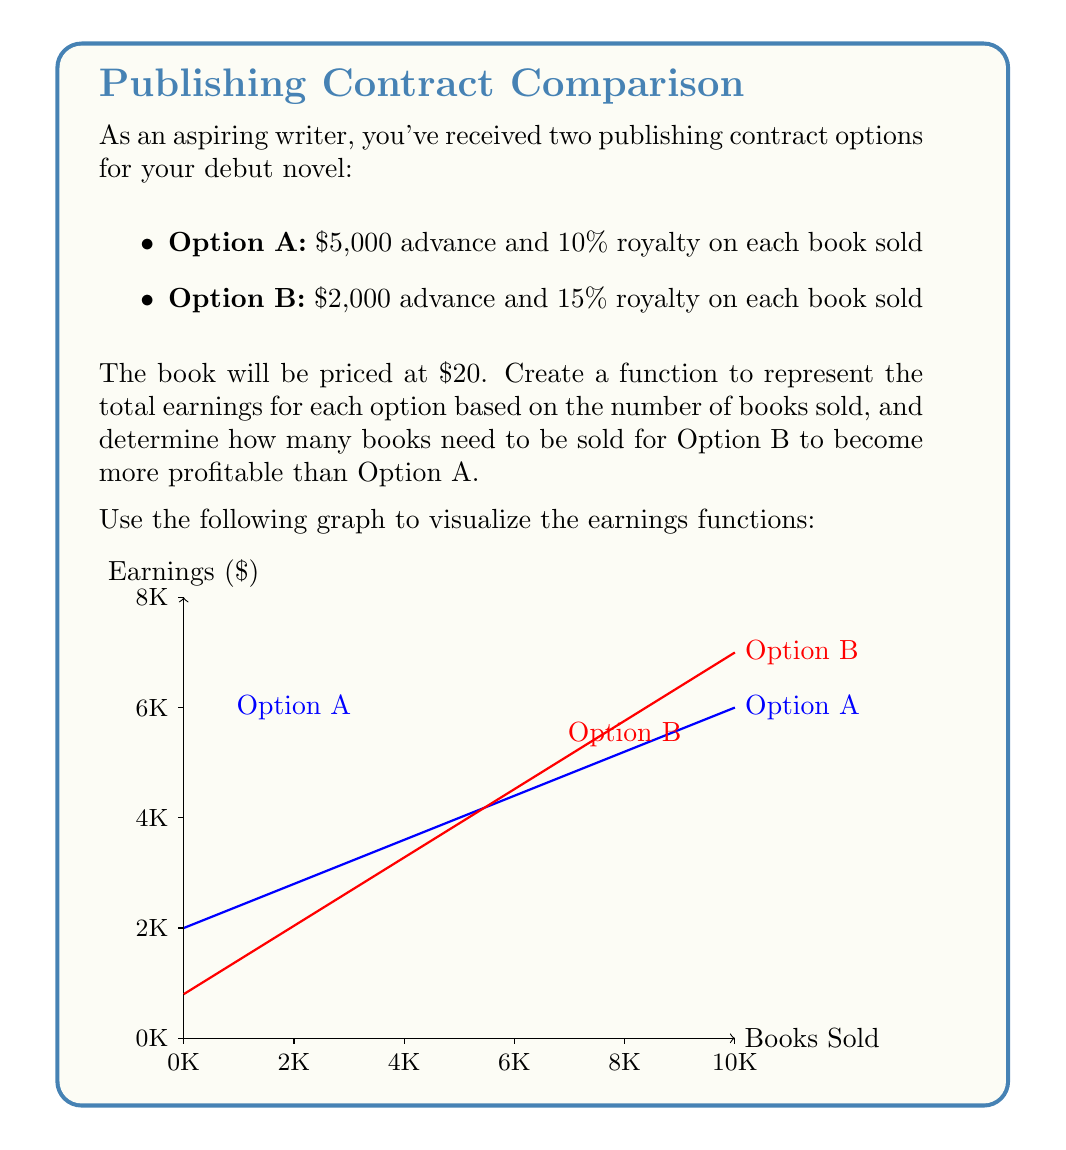Solve this math problem. Let's approach this step-by-step:

1) First, we need to create functions for each option:

   Option A: $f(x) = 5000 + 0.1 \cdot 20x$
   Option B: $g(x) = 2000 + 0.15 \cdot 20x$

   Where $x$ is the number of books sold.

2) To find where Option B becomes more profitable, we need to solve the equation:

   $f(x) = g(x)$

3) Substituting our functions:

   $5000 + 0.1 \cdot 20x = 2000 + 0.15 \cdot 20x$

4) Simplify:

   $5000 + 2x = 2000 + 3x$

5) Subtract 2000 from both sides:

   $3000 + 2x = 3x$

6) Subtract 2x from both sides:

   $3000 = x$

7) Therefore, Option B becomes more profitable after 3000 books are sold.

8) We can verify this by calculating the earnings at 3000 books:

   Option A: $5000 + 0.1 \cdot 20 \cdot 3000 = 11000$
   Option B: $2000 + 0.15 \cdot 20 \cdot 3000 = 11000$

   At 3001 books, Option B will earn $3 more than Option A.
Answer: 3000 books 